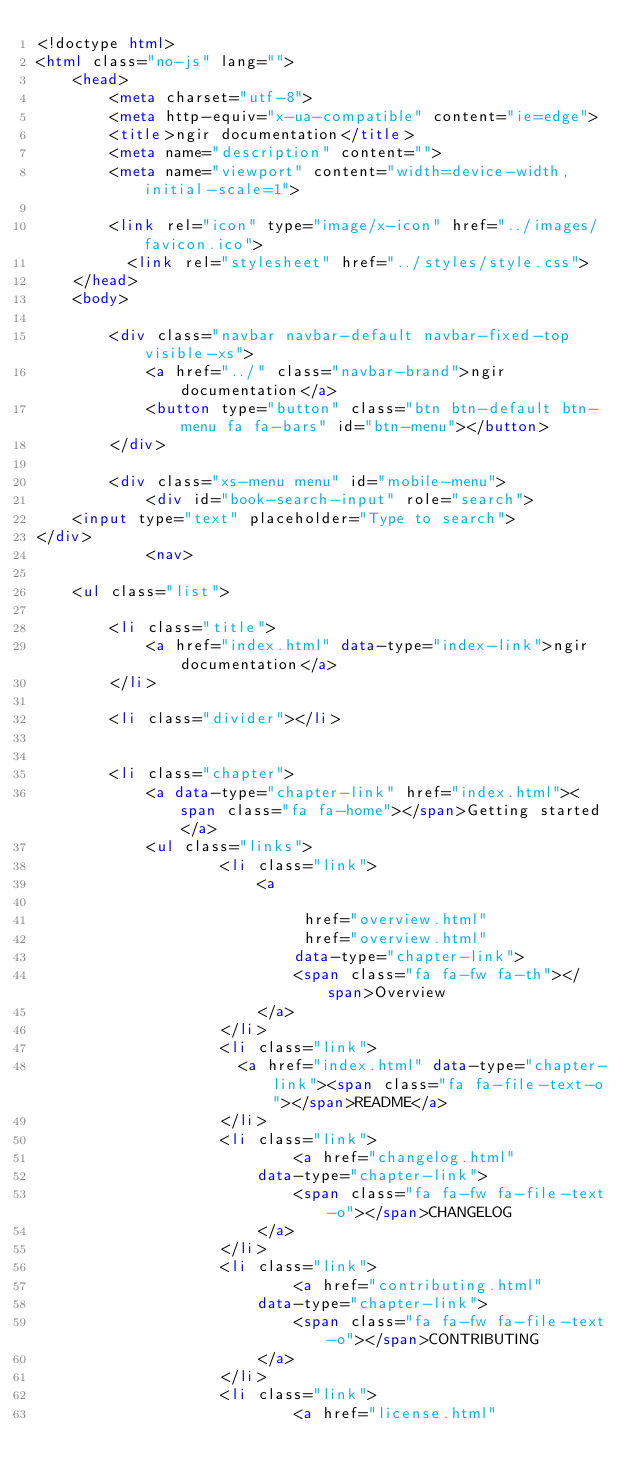<code> <loc_0><loc_0><loc_500><loc_500><_HTML_><!doctype html>
<html class="no-js" lang="">
    <head>
        <meta charset="utf-8">
        <meta http-equiv="x-ua-compatible" content="ie=edge">
        <title>ngir documentation</title>
        <meta name="description" content="">
        <meta name="viewport" content="width=device-width, initial-scale=1">

        <link rel="icon" type="image/x-icon" href="../images/favicon.ico">
	      <link rel="stylesheet" href="../styles/style.css">
    </head>
    <body>

        <div class="navbar navbar-default navbar-fixed-top visible-xs">
            <a href="../" class="navbar-brand">ngir documentation</a>
            <button type="button" class="btn btn-default btn-menu fa fa-bars" id="btn-menu"></button>
        </div>

        <div class="xs-menu menu" id="mobile-menu">
            <div id="book-search-input" role="search">
    <input type="text" placeholder="Type to search">
</div>
            <nav>

    <ul class="list">

        <li class="title">
            <a href="index.html" data-type="index-link">ngir documentation</a>
        </li>

        <li class="divider"></li>


        <li class="chapter">
            <a data-type="chapter-link" href="index.html"><span class="fa fa-home"></span>Getting started</a>
            <ul class="links">
                    <li class="link">
                        <a 
                            
                             href="overview.html" 
                             href="overview.html" 
                            data-type="chapter-link">
                            <span class="fa fa-fw fa-th"></span>Overview
                        </a>
                    </li>
                    <li class="link">
                      <a href="index.html" data-type="chapter-link"><span class="fa fa-file-text-o"></span>README</a>
                    </li>
                    <li class="link">
                            <a href="changelog.html"
                        data-type="chapter-link">
                            <span class="fa fa-fw fa-file-text-o"></span>CHANGELOG
                        </a>
                    </li>
                    <li class="link">
                            <a href="contributing.html"
                        data-type="chapter-link">
                            <span class="fa fa-fw fa-file-text-o"></span>CONTRIBUTING
                        </a>
                    </li>
                    <li class="link">
                            <a href="license.html"</code> 